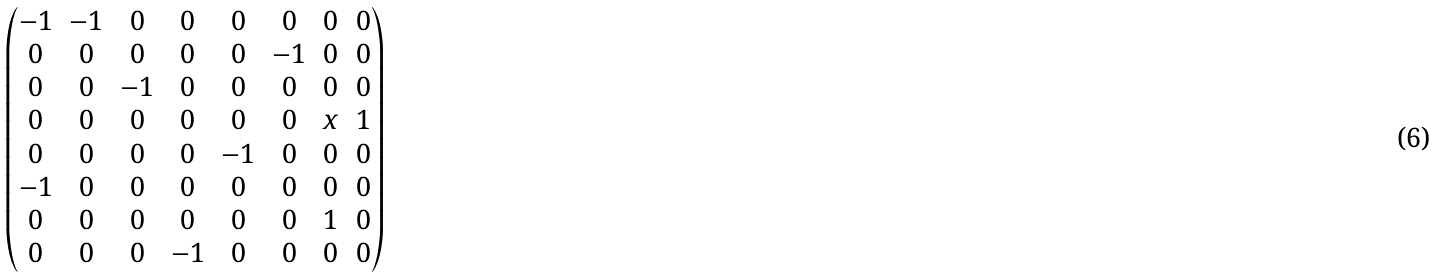Convert formula to latex. <formula><loc_0><loc_0><loc_500><loc_500>\begin{pmatrix} - 1 & - 1 & 0 & 0 & 0 & 0 & 0 & 0 \\ 0 & 0 & 0 & 0 & 0 & - 1 & 0 & 0 \\ 0 & 0 & - 1 & 0 & 0 & 0 & 0 & 0 \\ 0 & 0 & 0 & 0 & 0 & 0 & x & 1 \\ 0 & 0 & 0 & 0 & - 1 & 0 & 0 & 0 \\ - 1 & 0 & 0 & 0 & 0 & 0 & 0 & 0 \\ 0 & 0 & 0 & 0 & 0 & 0 & 1 & 0 \\ 0 & 0 & 0 & - 1 & 0 & 0 & 0 & 0 \end{pmatrix}</formula> 